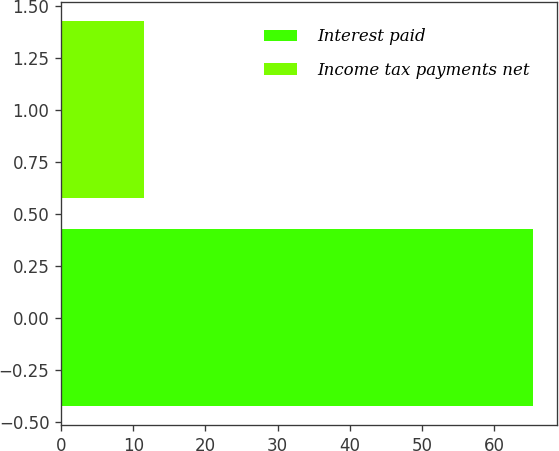<chart> <loc_0><loc_0><loc_500><loc_500><bar_chart><fcel>Interest paid<fcel>Income tax payments net<nl><fcel>65.4<fcel>11.5<nl></chart> 